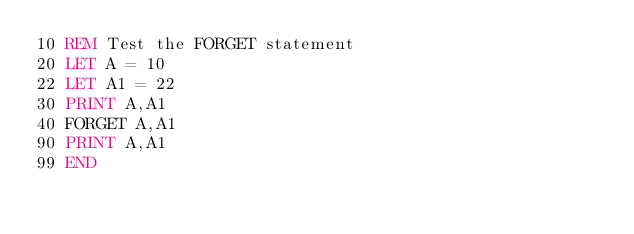<code> <loc_0><loc_0><loc_500><loc_500><_VisualBasic_>10 REM Test the FORGET statement
20 LET A = 10
22 LET A1 = 22
30 PRINT A,A1
40 FORGET A,A1
90 PRINT A,A1
99 END
</code> 